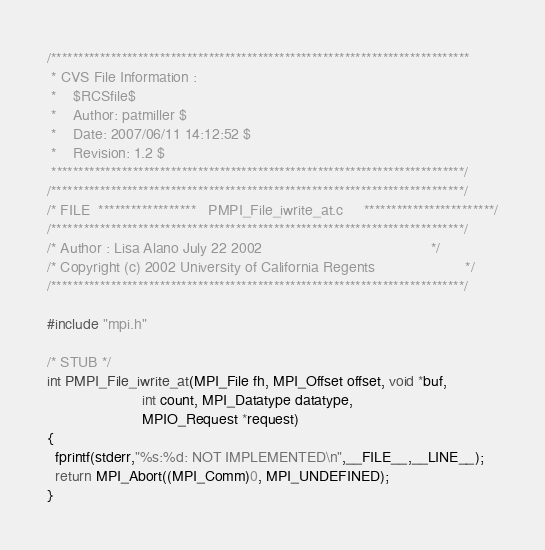<code> <loc_0><loc_0><loc_500><loc_500><_C_>/*****************************************************************************
 * CVS File Information :
 *    $RCSfile$
 *    Author: patmiller $
 *    Date: 2007/06/11 14:12:52 $
 *    Revision: 1.2 $
 ****************************************************************************/
/****************************************************************************/
/* FILE  ******************   PMPI_File_iwrite_at.c     ************************/
/****************************************************************************/
/* Author : Lisa Alano July 22 2002                                         */
/* Copyright (c) 2002 University of California Regents                      */
/****************************************************************************/

#include "mpi.h"

/* STUB */
int PMPI_File_iwrite_at(MPI_File fh, MPI_Offset offset, void *buf,
                       int count, MPI_Datatype datatype,
                       MPIO_Request *request)
{
  fprintf(stderr,"%s:%d: NOT IMPLEMENTED\n",__FILE__,__LINE__);
  return MPI_Abort((MPI_Comm)0, MPI_UNDEFINED);
}
</code> 